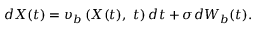<formula> <loc_0><loc_0><loc_500><loc_500>d X ( t ) = \upsilon _ { b } \left ( X ( t ) , \ t \right ) d t + \sigma d W _ { b } ( t ) .</formula> 